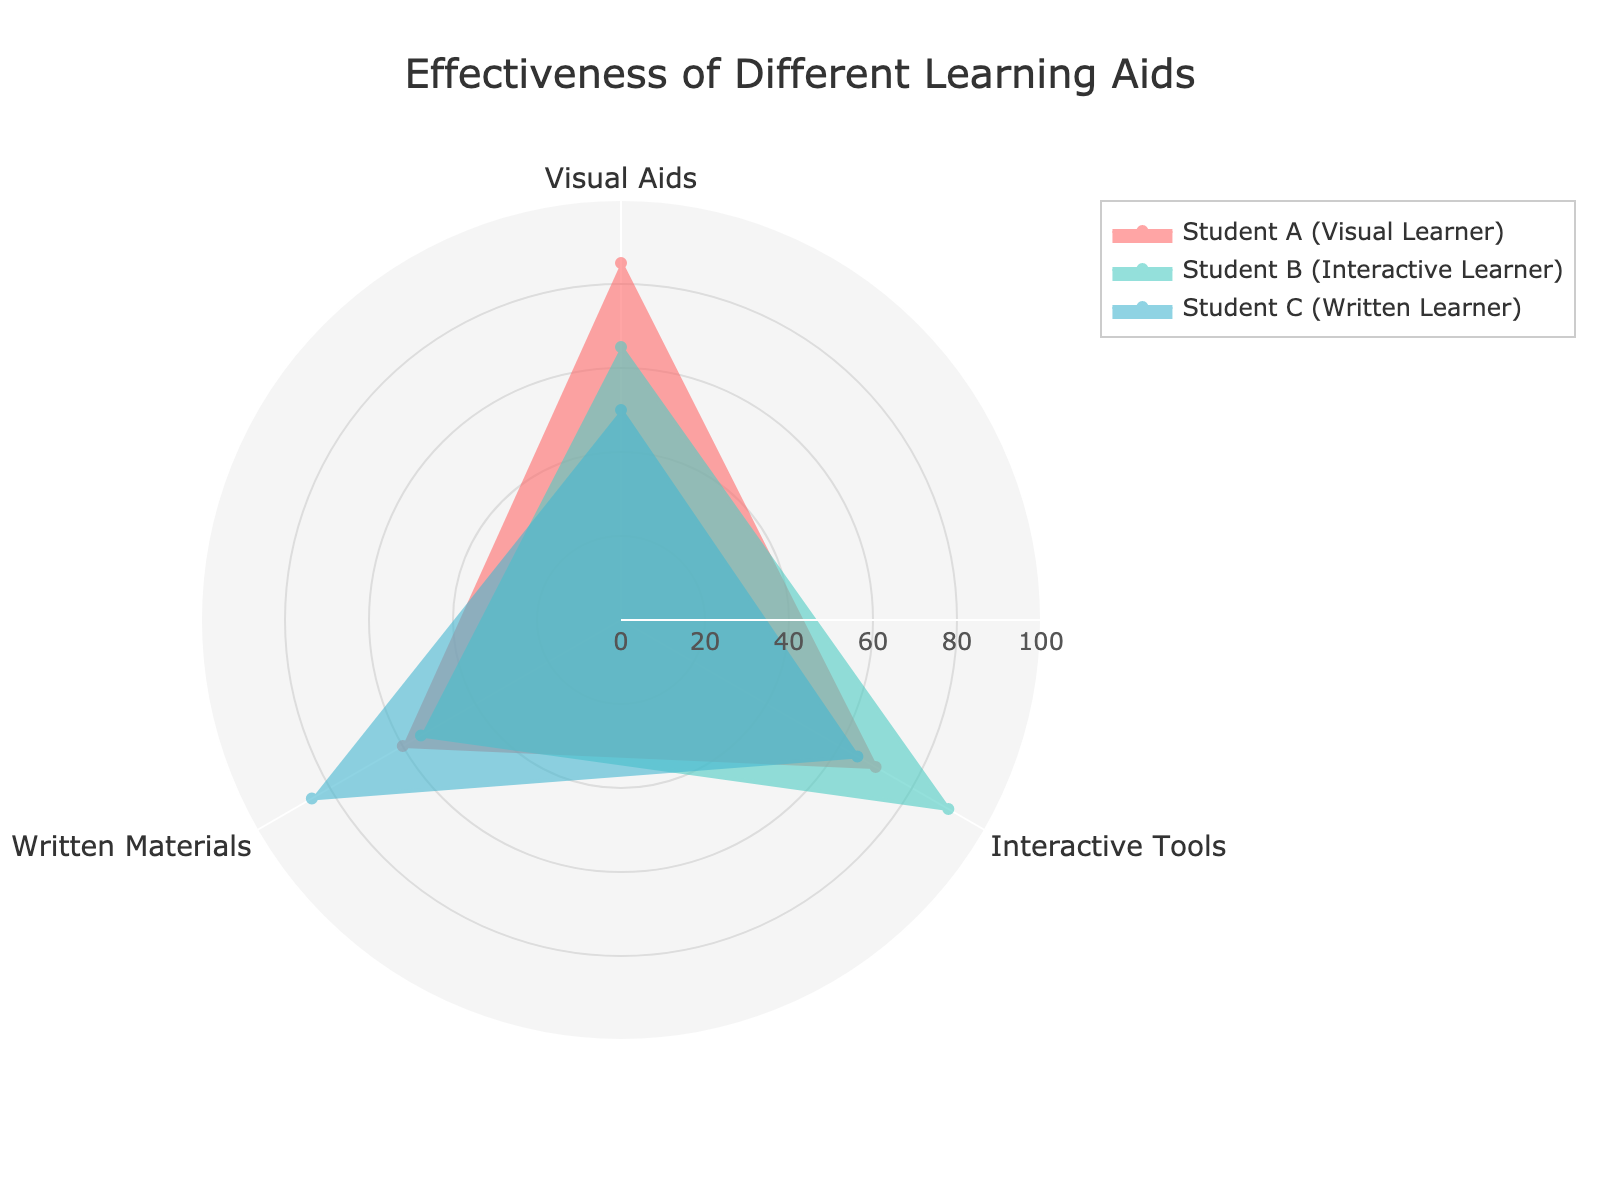what is the title of the chart? The title is located at the top-center of the figure and is styled to stand out.
Answer: Effectiveness of Different Learning Aids how many student groups are displayed on the chart? The radar chart displays distinct shaped areas each representing a student group, identified by their labels in the legend. There are three groups.
Answer: Three which learning aid is most effective for Student A (Visual Learner)? Look at the section of the chart corresponding to Student A and identify the highest value plotted for any of the learning aids.
Answer: Visual Aids which student group finds interactive tools most effective? Observe the segment for Interactive Tools and look for the label where the plotted value is the highest.
Answer: Student B (Interactive Learner) does Student C show a higher preference for written materials or visual aids? Compare the positions for Written Materials and Visual Aids on the Student C line. Written Materials has a higher value.
Answer: Written Materials what is the main color used to represent Student B (Interactive Learner)? Each group is represented by a different color, refer to the legend and the plot area.
Answer: Cyan how many learning aids have effectiveness scores below 70 for Student D? Trace the Student D line and count the segments where the value falls below 70.
Answer: One which student group's performance in visual aids and interactive tools differs the most? Compare the differences between Visual Aids and Interactive Tools' values for each group, focusing on the magnitude of change.
Answer: Student A (Visual Learner) what is the average effectiveness score for Student A across the three learning aids? Add up Student A's individual scores for the three learning aids and divide by three. (85+70+60)/3 = 215/3 = 71.67
Answer: 71.67 which student group exhibits the most balanced effectiveness across all three learning aids? Look for the group where values are most even and similar across the chart.
Answer: Student D (Mixed Learner) 